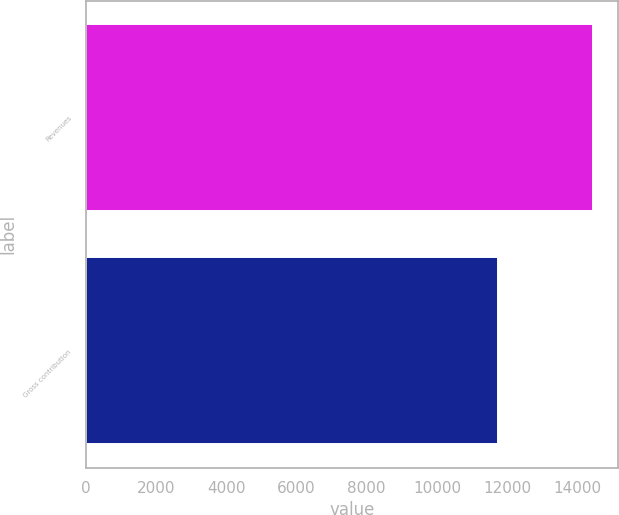Convert chart to OTSL. <chart><loc_0><loc_0><loc_500><loc_500><bar_chart><fcel>Revenues<fcel>Gross contribution<nl><fcel>14439<fcel>11725<nl></chart> 